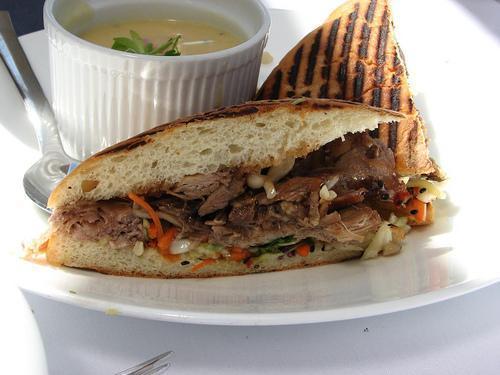How many sandwiches can be seen?
Give a very brief answer. 2. How many of these women are wearing pants?
Give a very brief answer. 0. 